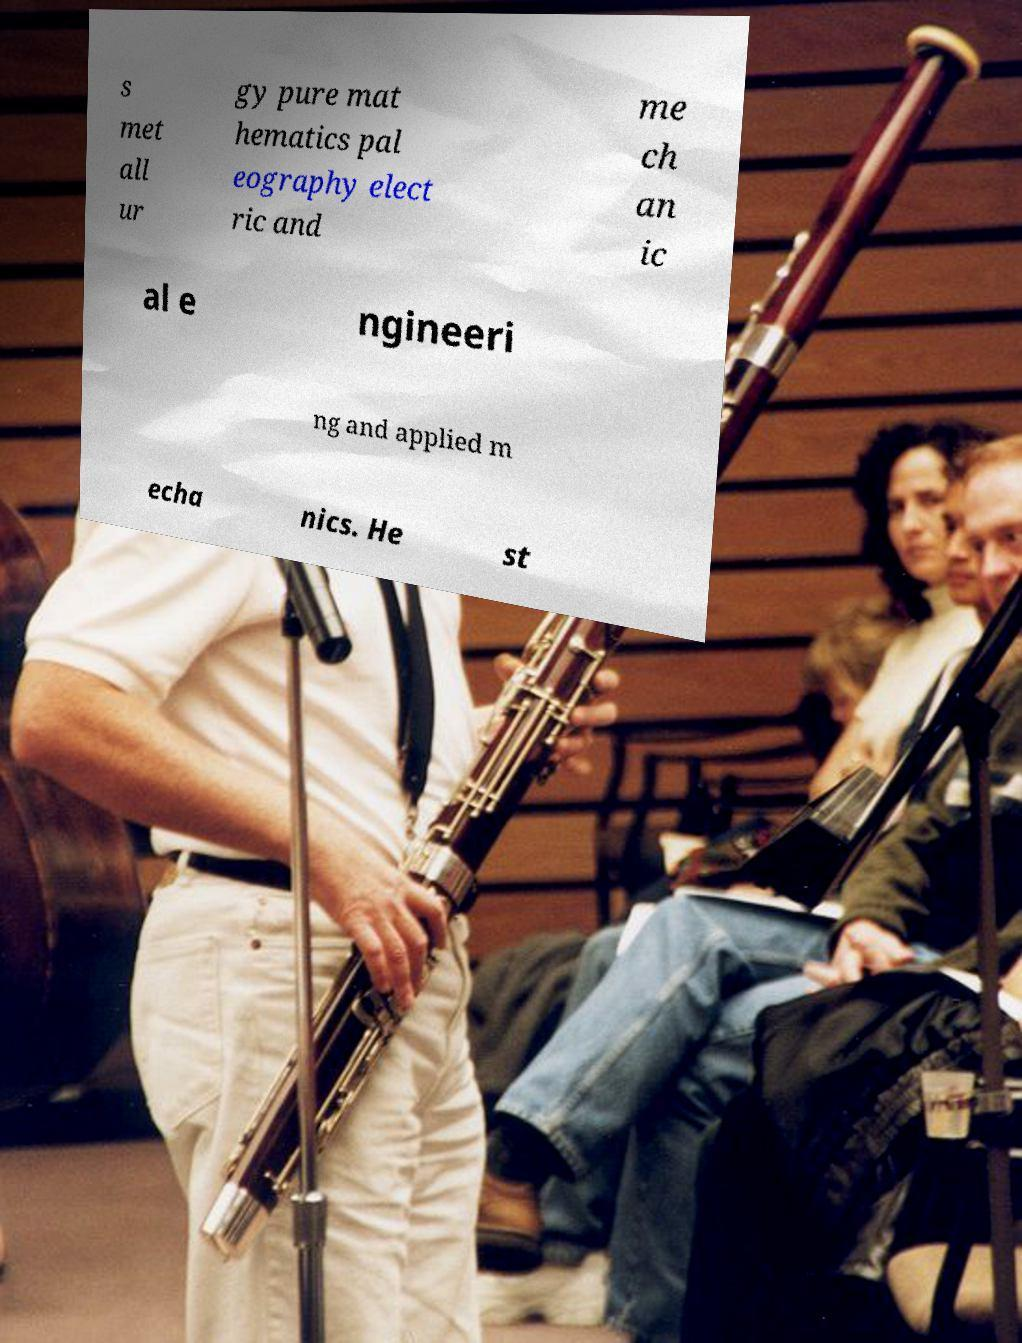Please identify and transcribe the text found in this image. s met all ur gy pure mat hematics pal eography elect ric and me ch an ic al e ngineeri ng and applied m echa nics. He st 